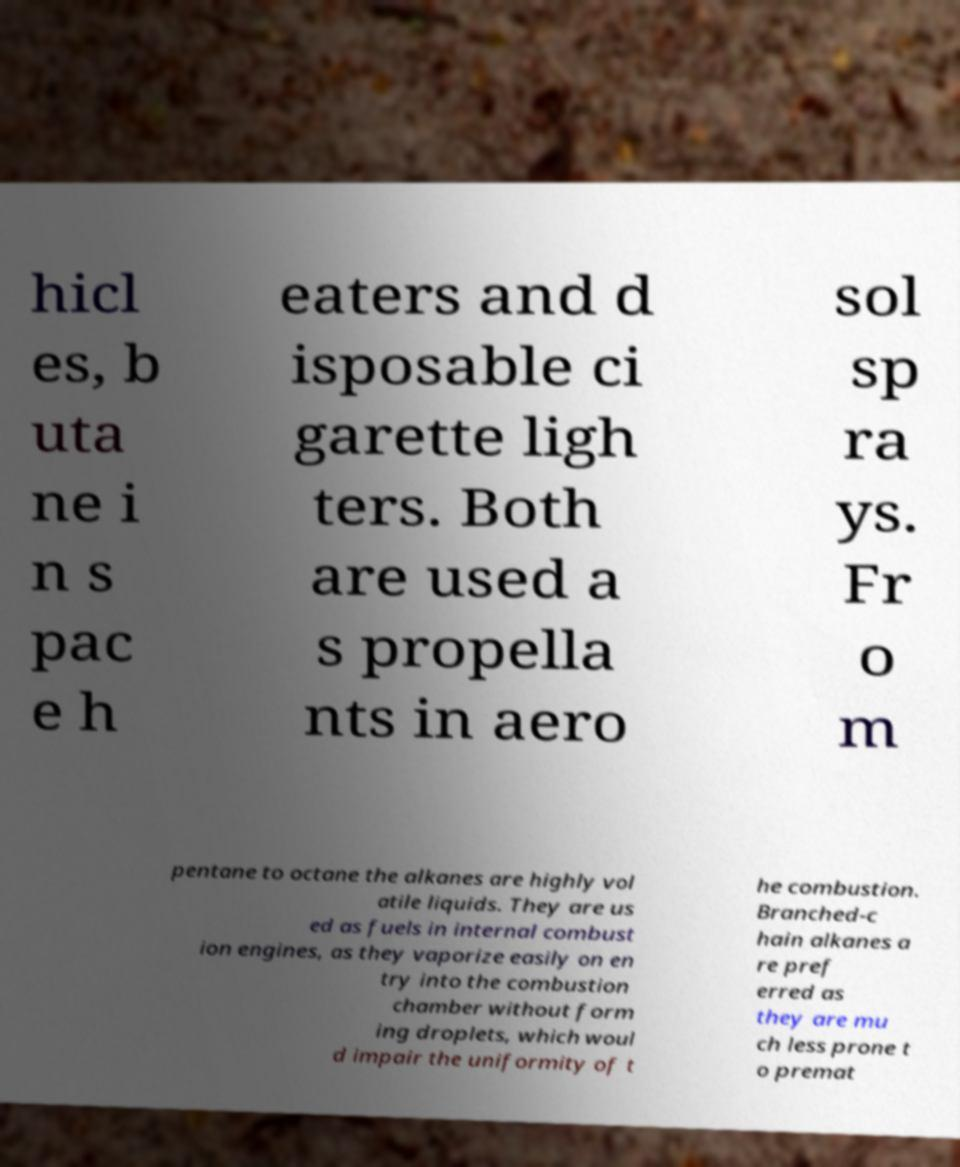Could you extract and type out the text from this image? hicl es, b uta ne i n s pac e h eaters and d isposable ci garette ligh ters. Both are used a s propella nts in aero sol sp ra ys. Fr o m pentane to octane the alkanes are highly vol atile liquids. They are us ed as fuels in internal combust ion engines, as they vaporize easily on en try into the combustion chamber without form ing droplets, which woul d impair the uniformity of t he combustion. Branched-c hain alkanes a re pref erred as they are mu ch less prone t o premat 